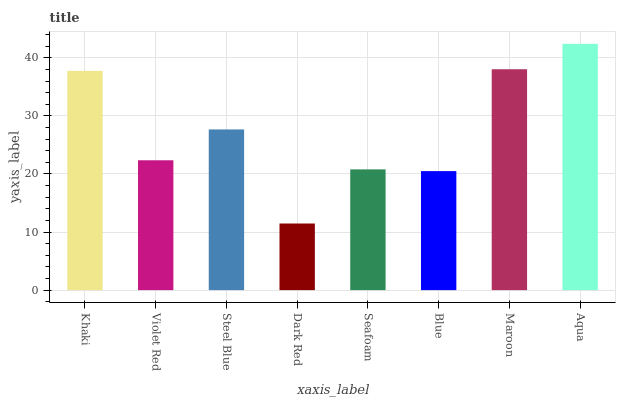Is Violet Red the minimum?
Answer yes or no. No. Is Violet Red the maximum?
Answer yes or no. No. Is Khaki greater than Violet Red?
Answer yes or no. Yes. Is Violet Red less than Khaki?
Answer yes or no. Yes. Is Violet Red greater than Khaki?
Answer yes or no. No. Is Khaki less than Violet Red?
Answer yes or no. No. Is Steel Blue the high median?
Answer yes or no. Yes. Is Violet Red the low median?
Answer yes or no. Yes. Is Seafoam the high median?
Answer yes or no. No. Is Maroon the low median?
Answer yes or no. No. 